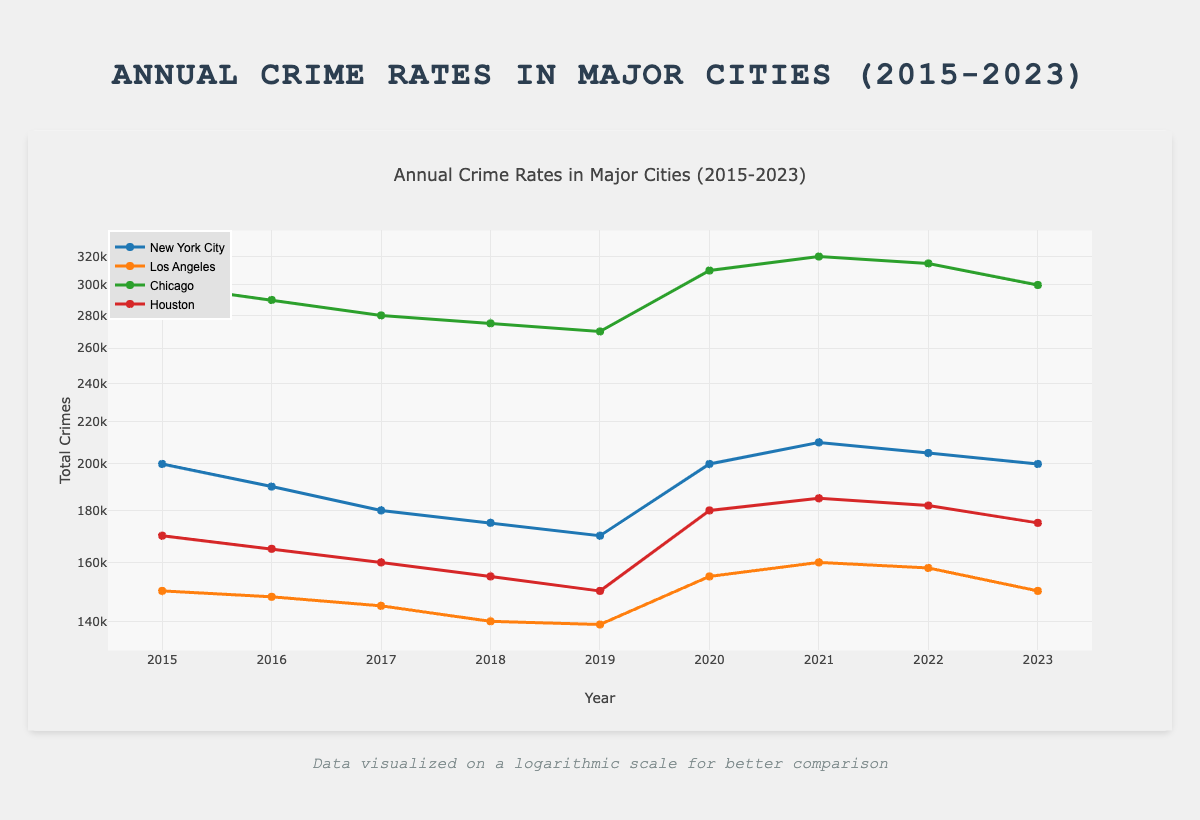What was the total number of crimes in New York City in 2015? The table indicates that in 2015, New York City had a total of 200,000 crimes reported. Therefore, the specific value can be directly retrieved from the data for that year and city.
Answer: 200000 Which city had the highest number of total crimes in 2021? In 2021, the total number of crimes in Chicago was 320,000, which is higher than the totals for both New York City (210,000) and Los Angeles (160,000). Thus, the highest was indeed in Chicago.
Answer: Chicago What is the average number of total crimes in Los Angeles from 2015 to 2023? To find the average, we add all the total crimes from each year for Los Angeles: (150,000 + 148,000 + 145,000 + 140,000 + 139,000 + 155,000 + 160,000 + 158,000 + 150,000) = 1,215,000. Then we divide by 9 years, which gives us an average of 1,215,000 / 9 = 135,000.
Answer: 135000 Did the total number of crimes in Houston increase from 2019 to 2020? In 2019, Houston reported 150,000 total crimes, and in 2020, it reported 180,000. Given that 180,000 is greater than 150,000, it confirms there was indeed an increase.
Answer: Yes What was the percentage decrease in total crimes in Chicago from 2015 to 2019? To find the percentage decrease, we first calculate the difference in total crimes from 2015 (300,000) to 2019 (270,000), which is 300,000 - 270,000 = 30,000. Next, we divide this difference by the original number (300,000) and multiply by 100 to get: (30,000 / 300,000) * 100 = 10%. Therefore, there was a 10% decrease in total crimes.
Answer: 10% 